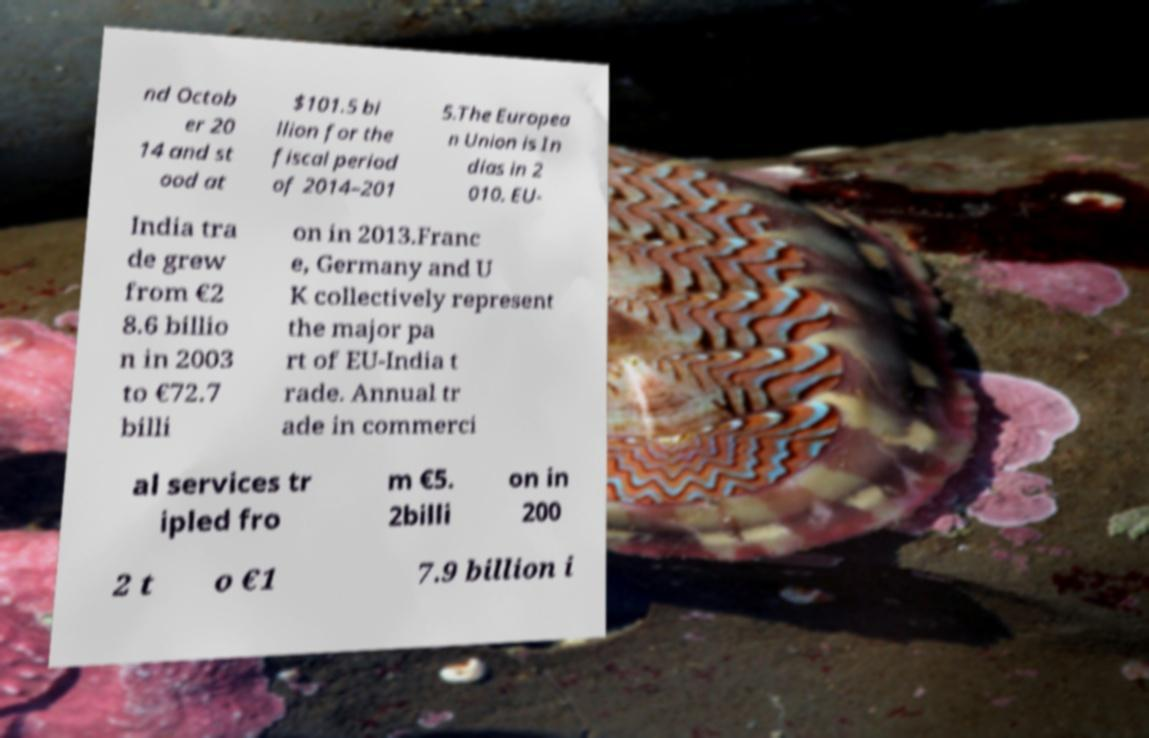Please identify and transcribe the text found in this image. nd Octob er 20 14 and st ood at $101.5 bi llion for the fiscal period of 2014–201 5.The Europea n Union is In dias in 2 010. EU- India tra de grew from €2 8.6 billio n in 2003 to €72.7 billi on in 2013.Franc e, Germany and U K collectively represent the major pa rt of EU-India t rade. Annual tr ade in commerci al services tr ipled fro m €5. 2billi on in 200 2 t o €1 7.9 billion i 